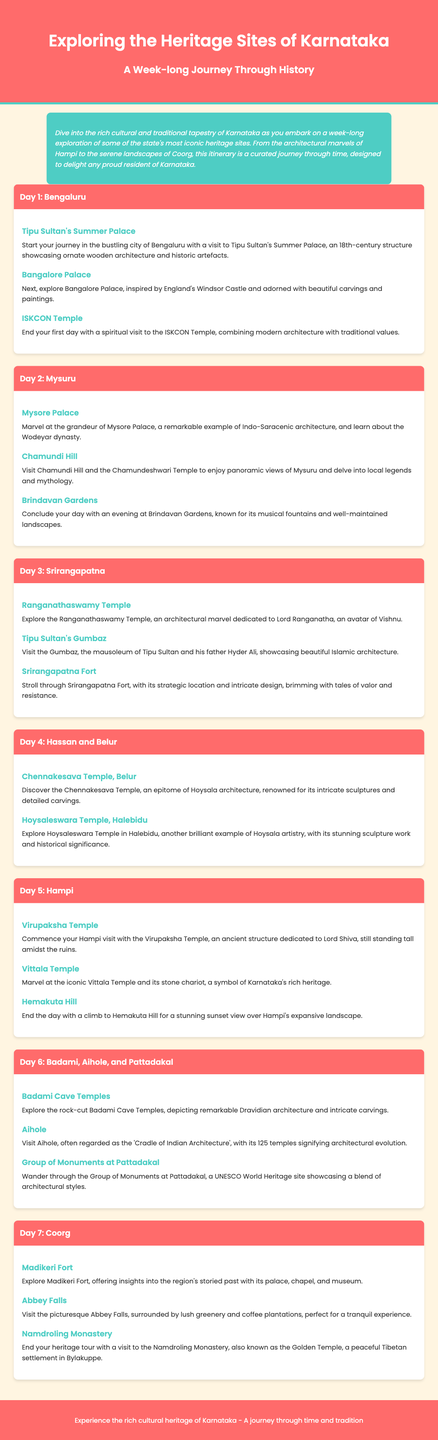What is the first heritage site visited in Bengaluru? The first heritage site visited in Bengaluru is Tipu Sultan's Summer Palace.
Answer: Tipu Sultan's Summer Palace How many days does the itinerary cover? The itinerary covers a total of 7 days.
Answer: 7 days Which temple in Mysuru offers panoramic views? Chamundi Hill and the Chamundeshwari Temple offer panoramic views of Mysuru.
Answer: Chamundi Hill What architectural style is Mysore Palace an example of? Mysore Palace is a remarkable example of Indo-Saracenic architecture.
Answer: Indo-Saracenic What is the UNESCO World Heritage site mentioned in the itinerary? The Group of Monuments at Pattadakal is a UNESCO World Heritage site.
Answer: Group of Monuments at Pattadakal Which destination concludes the week-long journey? The week-long journey concludes in Coorg.
Answer: Coorg What is the significant feature of the Vittala Temple? The significant feature of the Vittala Temple is its stone chariot.
Answer: Stone chariot How many activities are planned for Day 6? There are three activities planned for Day 6.
Answer: Three activities 